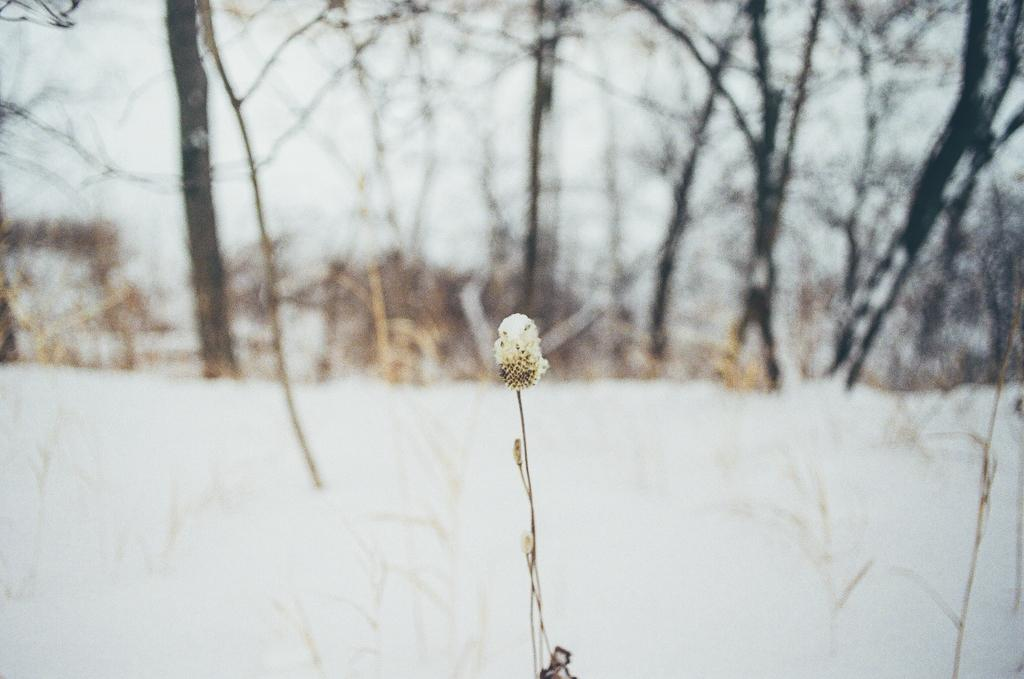What is the main subject of the image? There is a bud with a stem in the image. What can be seen in the background of the image? There is snow and trees in the background of the image. How would you describe the overall appearance of the image? The image appears slightly blurred. Where is the doctor located in the image? There is no doctor present in the image. What type of bead is used to decorate the bud in the image? There are no beads present in the image; it features a bud with a stem. 